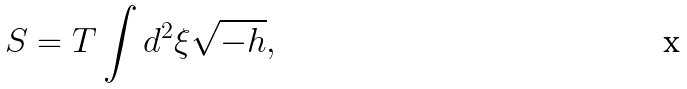Convert formula to latex. <formula><loc_0><loc_0><loc_500><loc_500>S = T \int d ^ { 2 } \xi \sqrt { - h } ,</formula> 